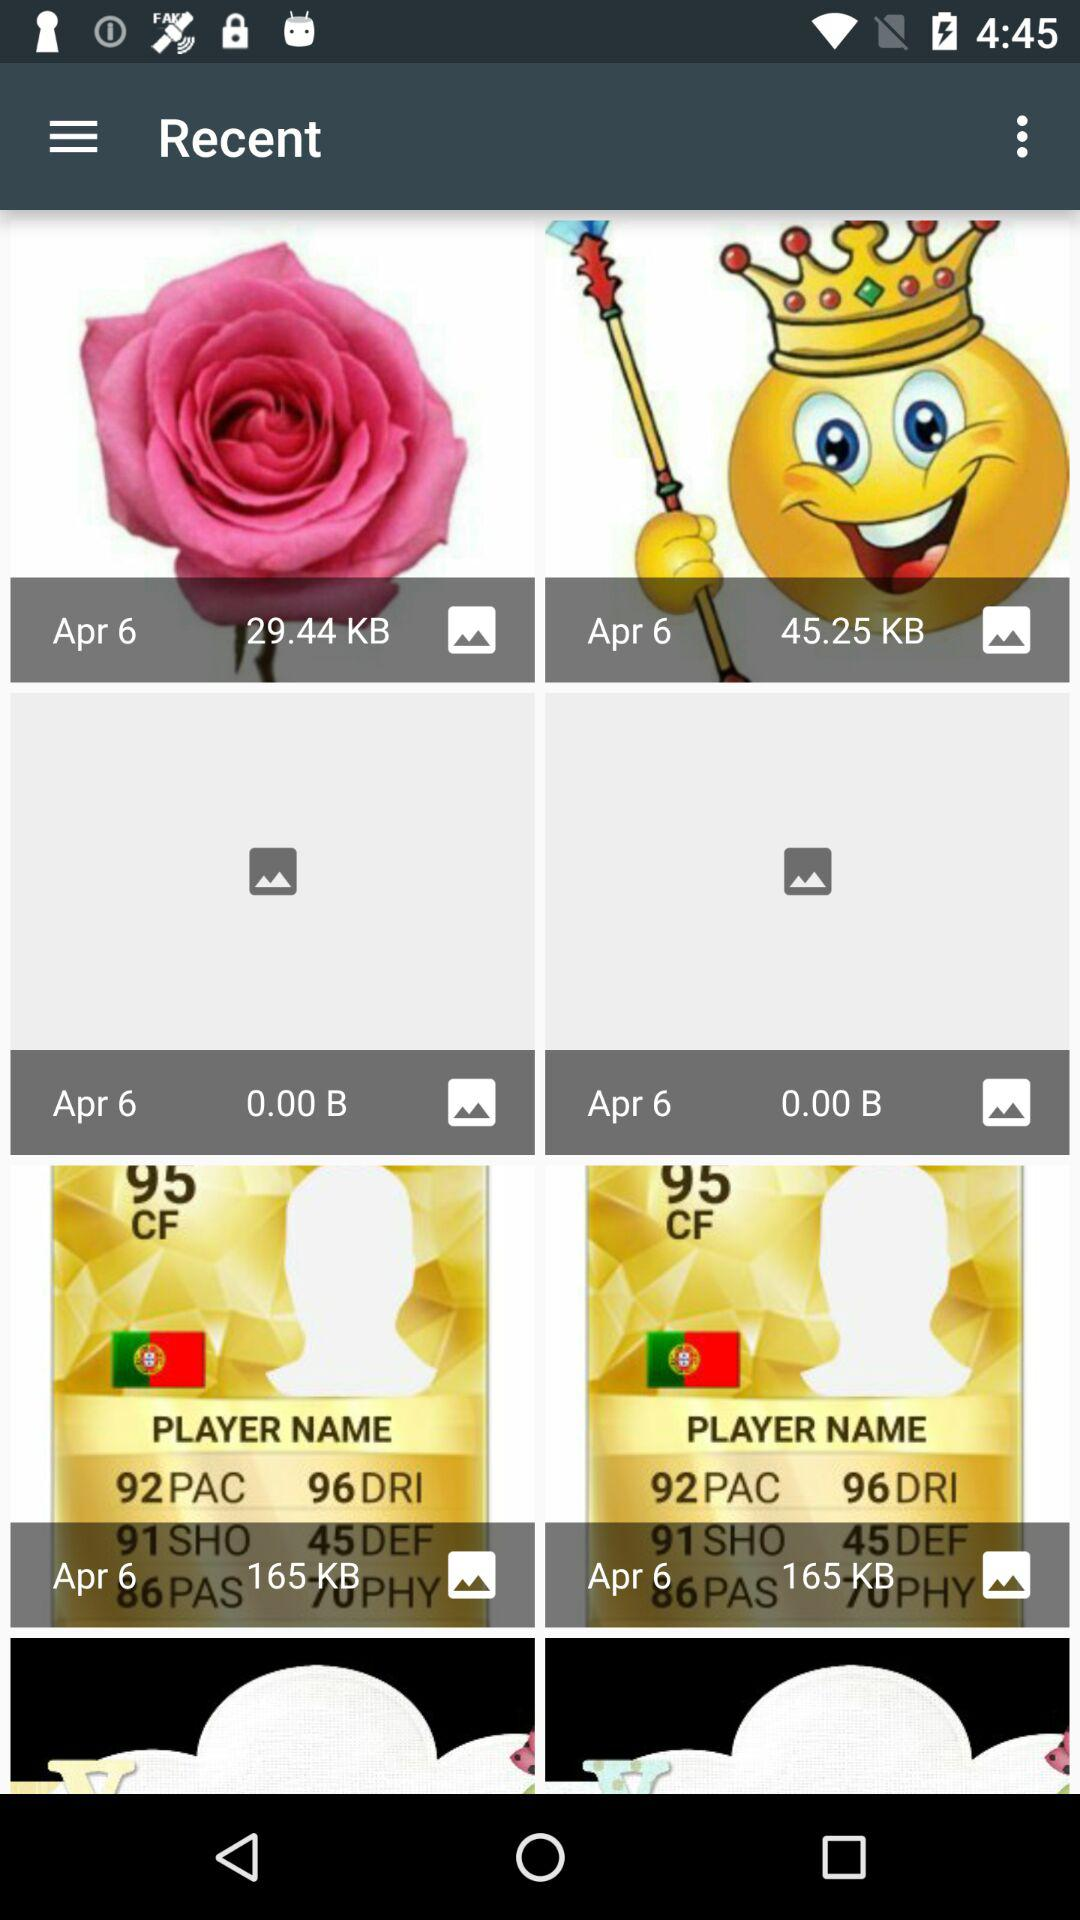On what date was the image whose size is 45.25 KB saved? The date on which the image was saved is April 6. 